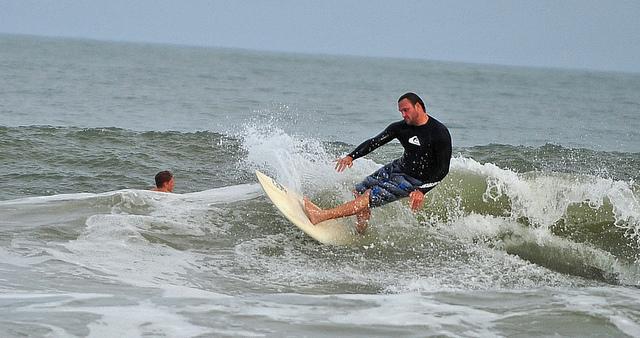How many people are near this wave?
Give a very brief answer. 2. How many red buses are there?
Give a very brief answer. 0. 